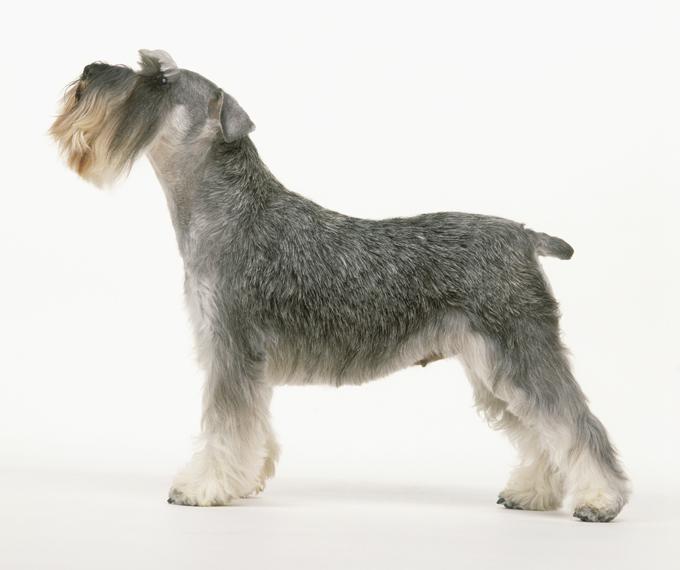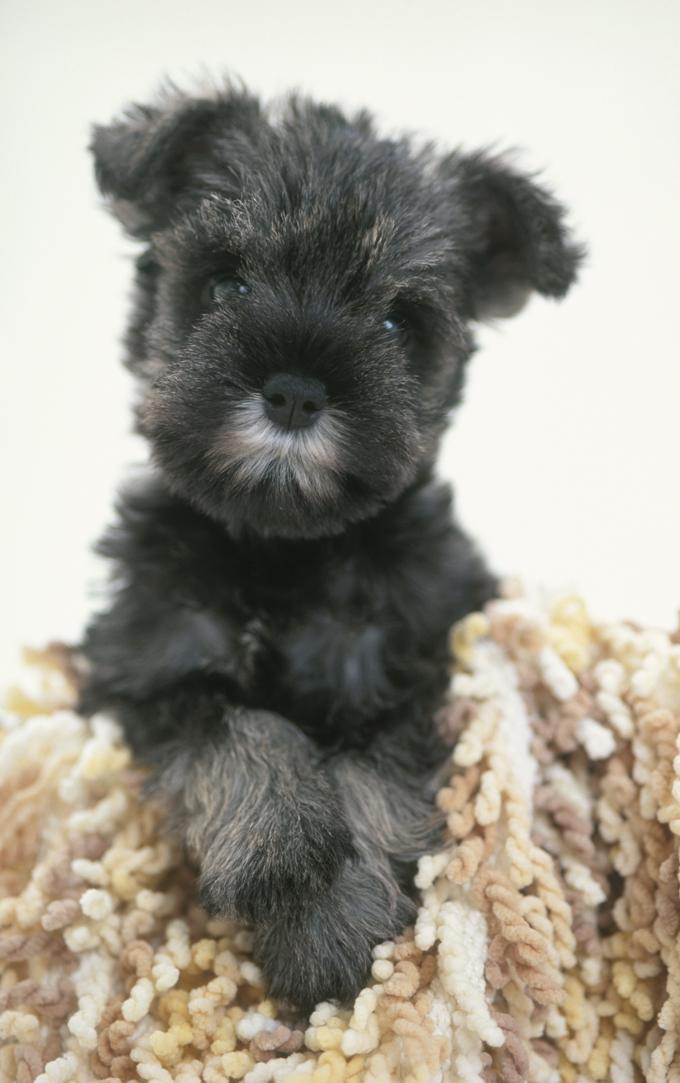The first image is the image on the left, the second image is the image on the right. Given the left and right images, does the statement "One dog's body is facing to the left." hold true? Answer yes or no. Yes. The first image is the image on the left, the second image is the image on the right. Given the left and right images, does the statement "An image shows exactly one schnauzer, which stands on all fours facing leftward." hold true? Answer yes or no. Yes. 